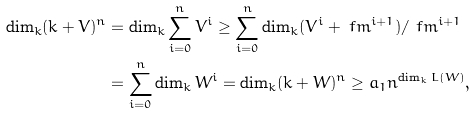<formula> <loc_0><loc_0><loc_500><loc_500>\dim _ { k } ( k + V ) ^ { n } & = \dim _ { k } \sum _ { i = 0 } ^ { n } V ^ { i } \geq \sum _ { i = 0 } ^ { n } \dim _ { k } ( V ^ { i } + \ f m ^ { i + 1 } ) / \ f m ^ { i + 1 } \\ & = \sum _ { i = 0 } ^ { n } \dim _ { k } W ^ { i } = \dim _ { k } ( k + W ) ^ { n } \geq a _ { 1 } n ^ { \dim _ { k } L ( W ) } ,</formula> 